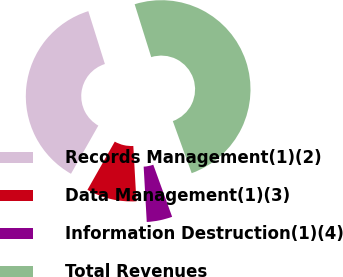Convert chart. <chart><loc_0><loc_0><loc_500><loc_500><pie_chart><fcel>Records Management(1)(2)<fcel>Data Management(1)(3)<fcel>Information Destruction(1)(4)<fcel>Total Revenues<nl><fcel>36.95%<fcel>9.1%<fcel>4.64%<fcel>49.3%<nl></chart> 